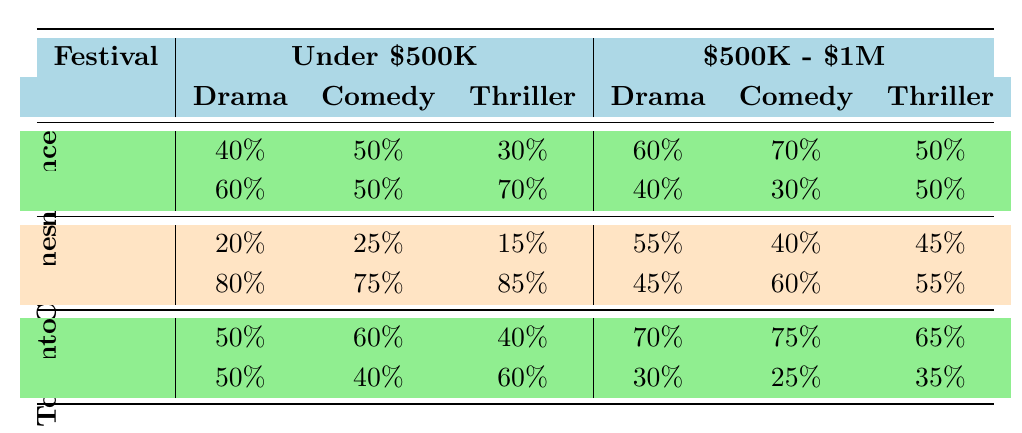What is the acceptance rate for Drama films at the Sundance Film Festival with a production budget under $500K? The acceptance rate for Drama films is calculated by taking the number of accepted films (40) and dividing it by the total number of submissions (40 accepted + 60 rejected = 100). Therefore, the acceptance rate is 40/100 = 40%.
Answer: 40% Which genre had the highest acceptance rate for films with a production budget between $500K and $1M at the Toronto International Film Festival? Looking at the table, the acceptance rates for genres with a production budget of $500K - $1M at the Toronto International Film Festival are as follows: Drama (70%), Comedy (75%), and Thriller (65%). The highest among these is Comedy at 75%.
Answer: Comedy Is the acceptance rate for Thriller films with an under $500K budget at the Cannes Film Festival higher than at Sundance Film Festival? At the Cannes Film Festival, the acceptance rate for Thriller films is 15%, while at Sundance Film Festival it is 30%. Since 15% is lower than 30%, the statement is false.
Answer: No What is the average acceptance rate for Comedy films across all three festivals for both budget categories? The acceptance rates for Comedy films are: Under $500K (Sundance 50%, Cannes 25%, Toronto 60%) and $500K - $1M (Sundance 70%, Cannes 40%, Toronto 75%). First, calculate the averages for each category: Under $500K: (50 + 25 + 60) / 3 = 45%; $500K - $1M: (70 + 40 + 75) / 3 = 61.67%. Next, the overall average is (45 + 61.67) / 2 = 53.84%.
Answer: 53.84% Are there more films accepted in the Drama genre than in the Comedy genre at the Sundance Film Festival for both budget categories combined? In the Sundance Film Festival, for Drama: Under $500K (40 accepted) and $500K - $1M (60 accepted), totaling 100 accepted Drama films. For Comedy: Under $500K (50 accepted) and $500K - $1M (70 accepted), totaling 120 accepted Comedy films. Since 100 is less than 120, the answer is no.
Answer: No 